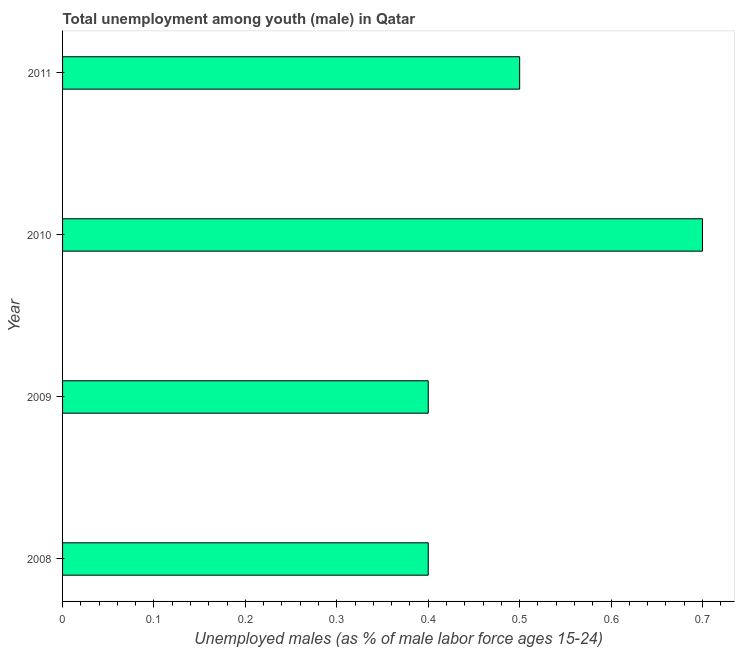What is the title of the graph?
Your response must be concise. Total unemployment among youth (male) in Qatar. What is the label or title of the X-axis?
Your answer should be very brief. Unemployed males (as % of male labor force ages 15-24). What is the label or title of the Y-axis?
Your answer should be very brief. Year. What is the unemployed male youth population in 2008?
Your answer should be compact. 0.4. Across all years, what is the maximum unemployed male youth population?
Provide a short and direct response. 0.7. Across all years, what is the minimum unemployed male youth population?
Your answer should be compact. 0.4. What is the sum of the unemployed male youth population?
Ensure brevity in your answer.  2. What is the average unemployed male youth population per year?
Ensure brevity in your answer.  0.5. What is the median unemployed male youth population?
Offer a terse response. 0.45. Is the difference between the unemployed male youth population in 2008 and 2011 greater than the difference between any two years?
Ensure brevity in your answer.  No. Is the sum of the unemployed male youth population in 2010 and 2011 greater than the maximum unemployed male youth population across all years?
Ensure brevity in your answer.  Yes. Are all the bars in the graph horizontal?
Provide a succinct answer. Yes. How many years are there in the graph?
Give a very brief answer. 4. What is the Unemployed males (as % of male labor force ages 15-24) in 2008?
Provide a succinct answer. 0.4. What is the Unemployed males (as % of male labor force ages 15-24) of 2009?
Offer a terse response. 0.4. What is the Unemployed males (as % of male labor force ages 15-24) in 2010?
Ensure brevity in your answer.  0.7. What is the difference between the Unemployed males (as % of male labor force ages 15-24) in 2008 and 2010?
Your answer should be very brief. -0.3. What is the difference between the Unemployed males (as % of male labor force ages 15-24) in 2008 and 2011?
Keep it short and to the point. -0.1. What is the difference between the Unemployed males (as % of male labor force ages 15-24) in 2010 and 2011?
Give a very brief answer. 0.2. What is the ratio of the Unemployed males (as % of male labor force ages 15-24) in 2008 to that in 2009?
Your answer should be very brief. 1. What is the ratio of the Unemployed males (as % of male labor force ages 15-24) in 2008 to that in 2010?
Provide a succinct answer. 0.57. What is the ratio of the Unemployed males (as % of male labor force ages 15-24) in 2008 to that in 2011?
Make the answer very short. 0.8. What is the ratio of the Unemployed males (as % of male labor force ages 15-24) in 2009 to that in 2010?
Ensure brevity in your answer.  0.57. What is the ratio of the Unemployed males (as % of male labor force ages 15-24) in 2009 to that in 2011?
Keep it short and to the point. 0.8. What is the ratio of the Unemployed males (as % of male labor force ages 15-24) in 2010 to that in 2011?
Offer a terse response. 1.4. 